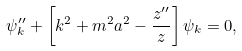<formula> <loc_0><loc_0><loc_500><loc_500>\psi _ { k } ^ { \prime \prime } + \left [ k ^ { 2 } + m ^ { 2 } a ^ { 2 } - \frac { z ^ { \prime \prime } } { z } \right ] \psi _ { k } = 0 ,</formula> 